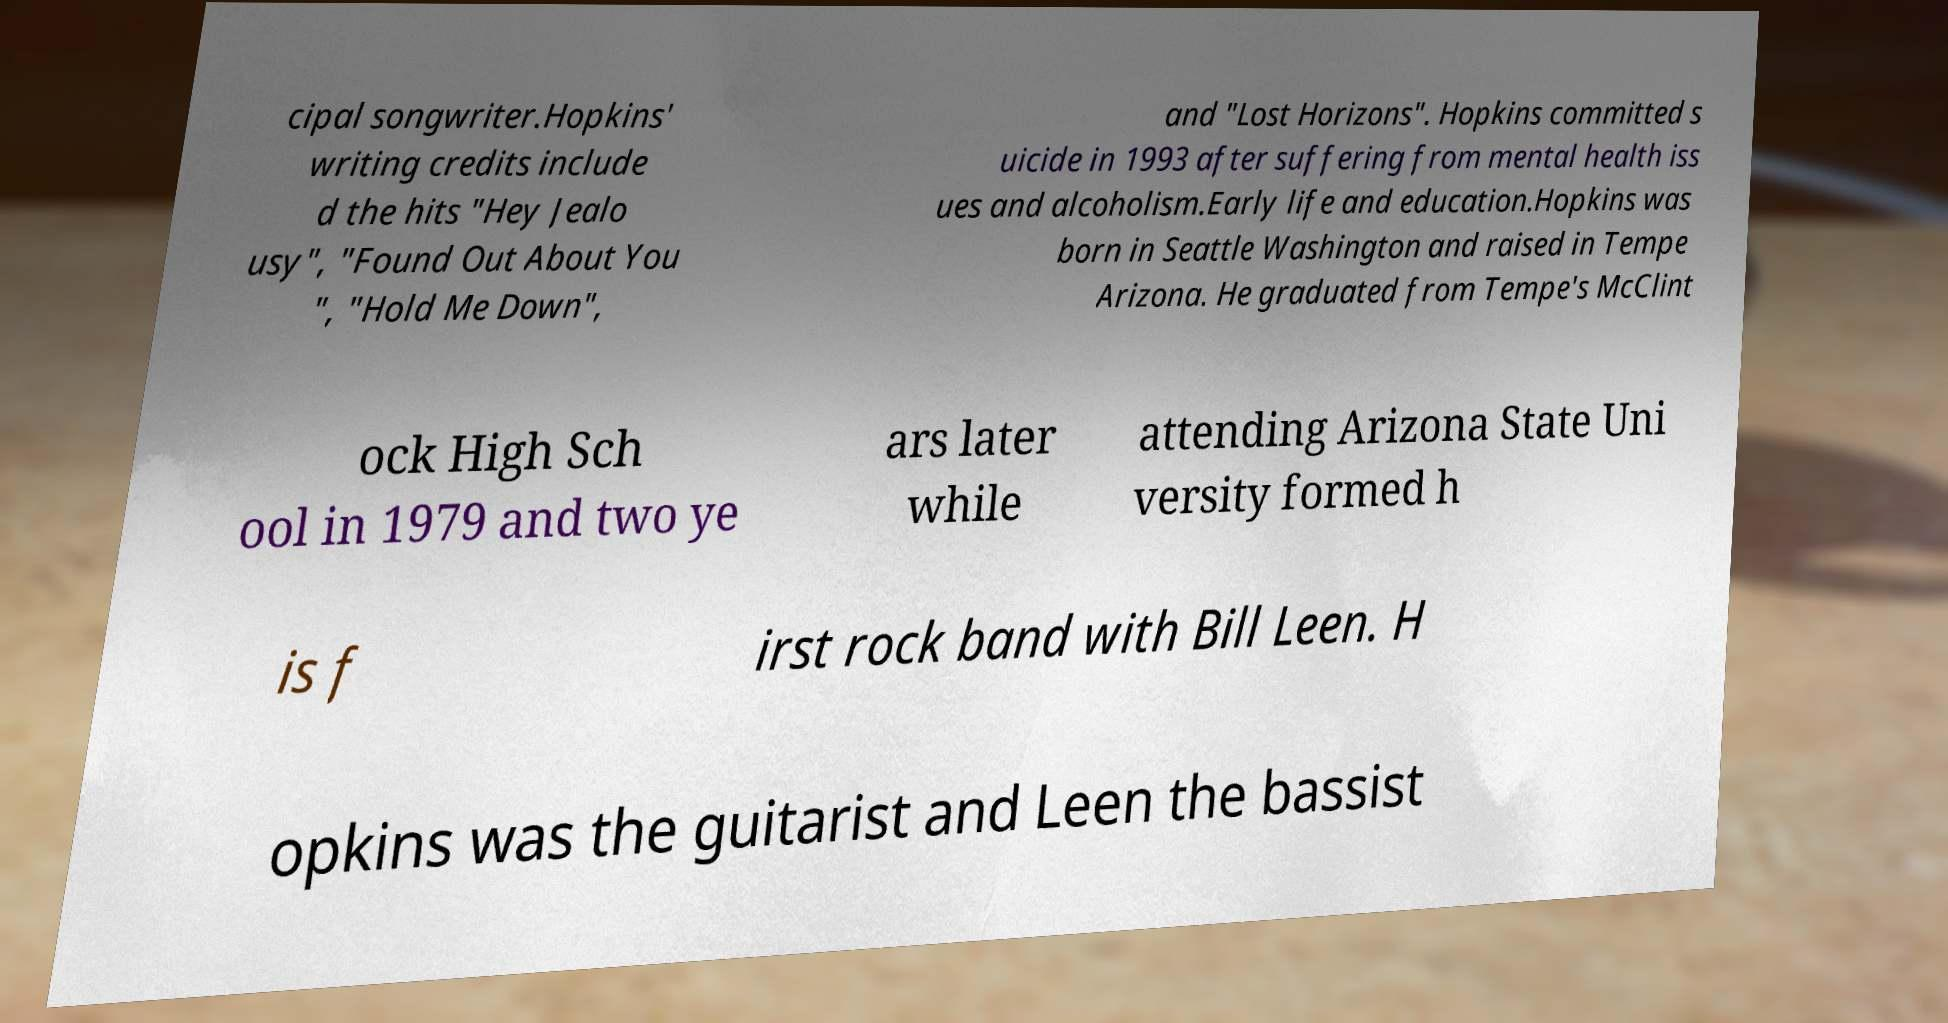I need the written content from this picture converted into text. Can you do that? cipal songwriter.Hopkins' writing credits include d the hits "Hey Jealo usy", "Found Out About You ", "Hold Me Down", and "Lost Horizons". Hopkins committed s uicide in 1993 after suffering from mental health iss ues and alcoholism.Early life and education.Hopkins was born in Seattle Washington and raised in Tempe Arizona. He graduated from Tempe's McClint ock High Sch ool in 1979 and two ye ars later while attending Arizona State Uni versity formed h is f irst rock band with Bill Leen. H opkins was the guitarist and Leen the bassist 